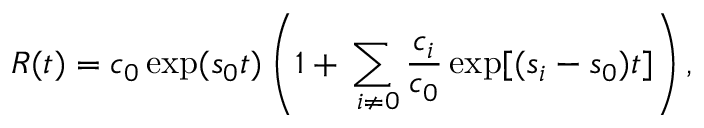<formula> <loc_0><loc_0><loc_500><loc_500>R ( t ) = { { c } _ { 0 } } \exp ( { { s } _ { 0 } } t ) \left ( 1 + \sum _ { i \ne 0 } { \frac { { { c } _ { i } } } { { { c } _ { 0 } } } \exp [ ( { { s } _ { i } } - { { s } _ { 0 } } ) t ] } \right ) ,</formula> 